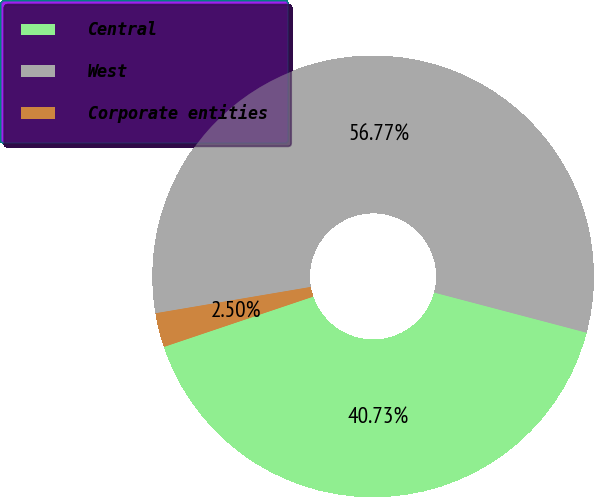Convert chart to OTSL. <chart><loc_0><loc_0><loc_500><loc_500><pie_chart><fcel>Central<fcel>West<fcel>Corporate entities<nl><fcel>40.73%<fcel>56.78%<fcel>2.5%<nl></chart> 